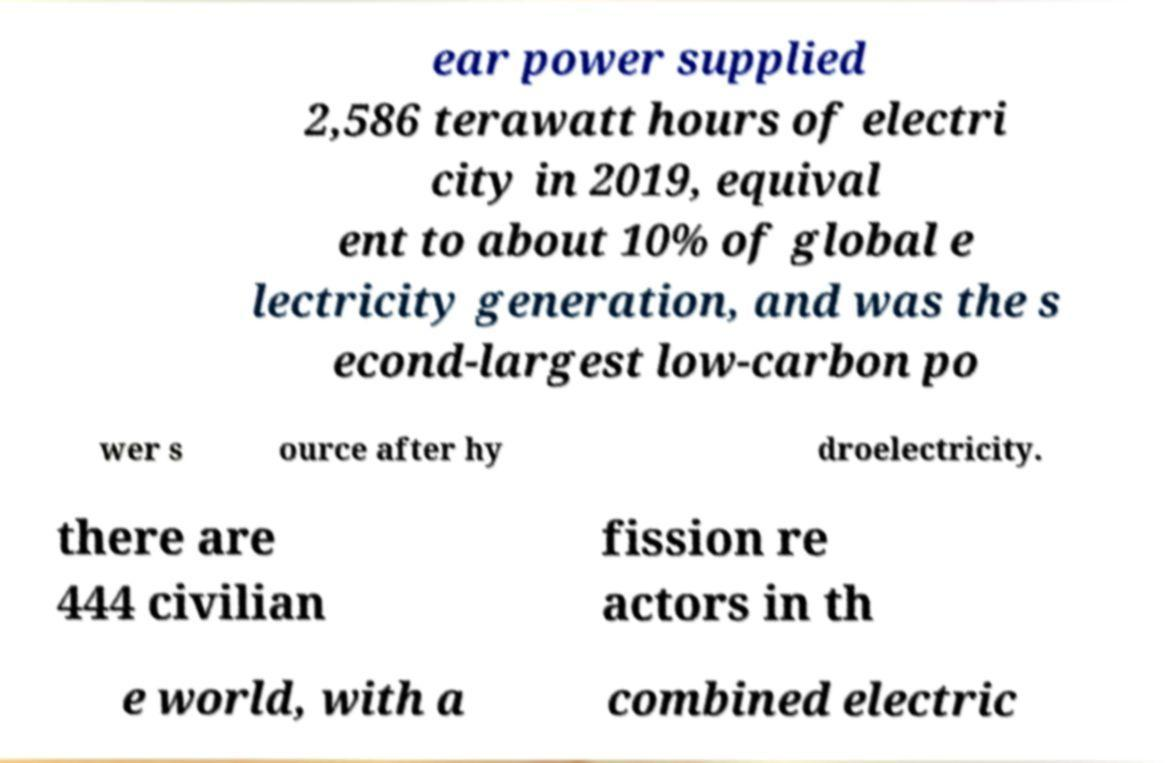Could you extract and type out the text from this image? ear power supplied 2,586 terawatt hours of electri city in 2019, equival ent to about 10% of global e lectricity generation, and was the s econd-largest low-carbon po wer s ource after hy droelectricity. there are 444 civilian fission re actors in th e world, with a combined electric 